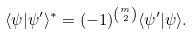Convert formula to latex. <formula><loc_0><loc_0><loc_500><loc_500>\langle \psi | \psi ^ { \prime } \rangle ^ { \ast } = ( - 1 ) ^ { { \binom { m } { 2 } } } \langle \psi ^ { \prime } | \psi \rangle .</formula> 